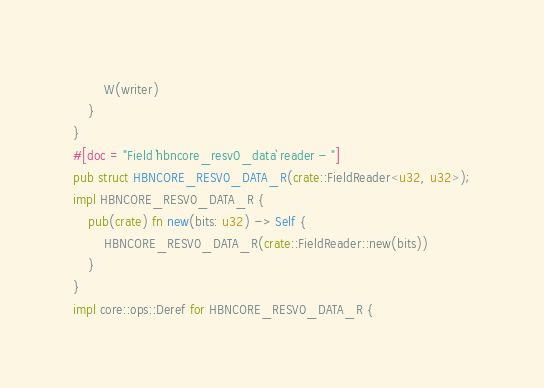<code> <loc_0><loc_0><loc_500><loc_500><_Rust_>        W(writer)
    }
}
#[doc = "Field `hbncore_resv0_data` reader - "]
pub struct HBNCORE_RESV0_DATA_R(crate::FieldReader<u32, u32>);
impl HBNCORE_RESV0_DATA_R {
    pub(crate) fn new(bits: u32) -> Self {
        HBNCORE_RESV0_DATA_R(crate::FieldReader::new(bits))
    }
}
impl core::ops::Deref for HBNCORE_RESV0_DATA_R {</code> 